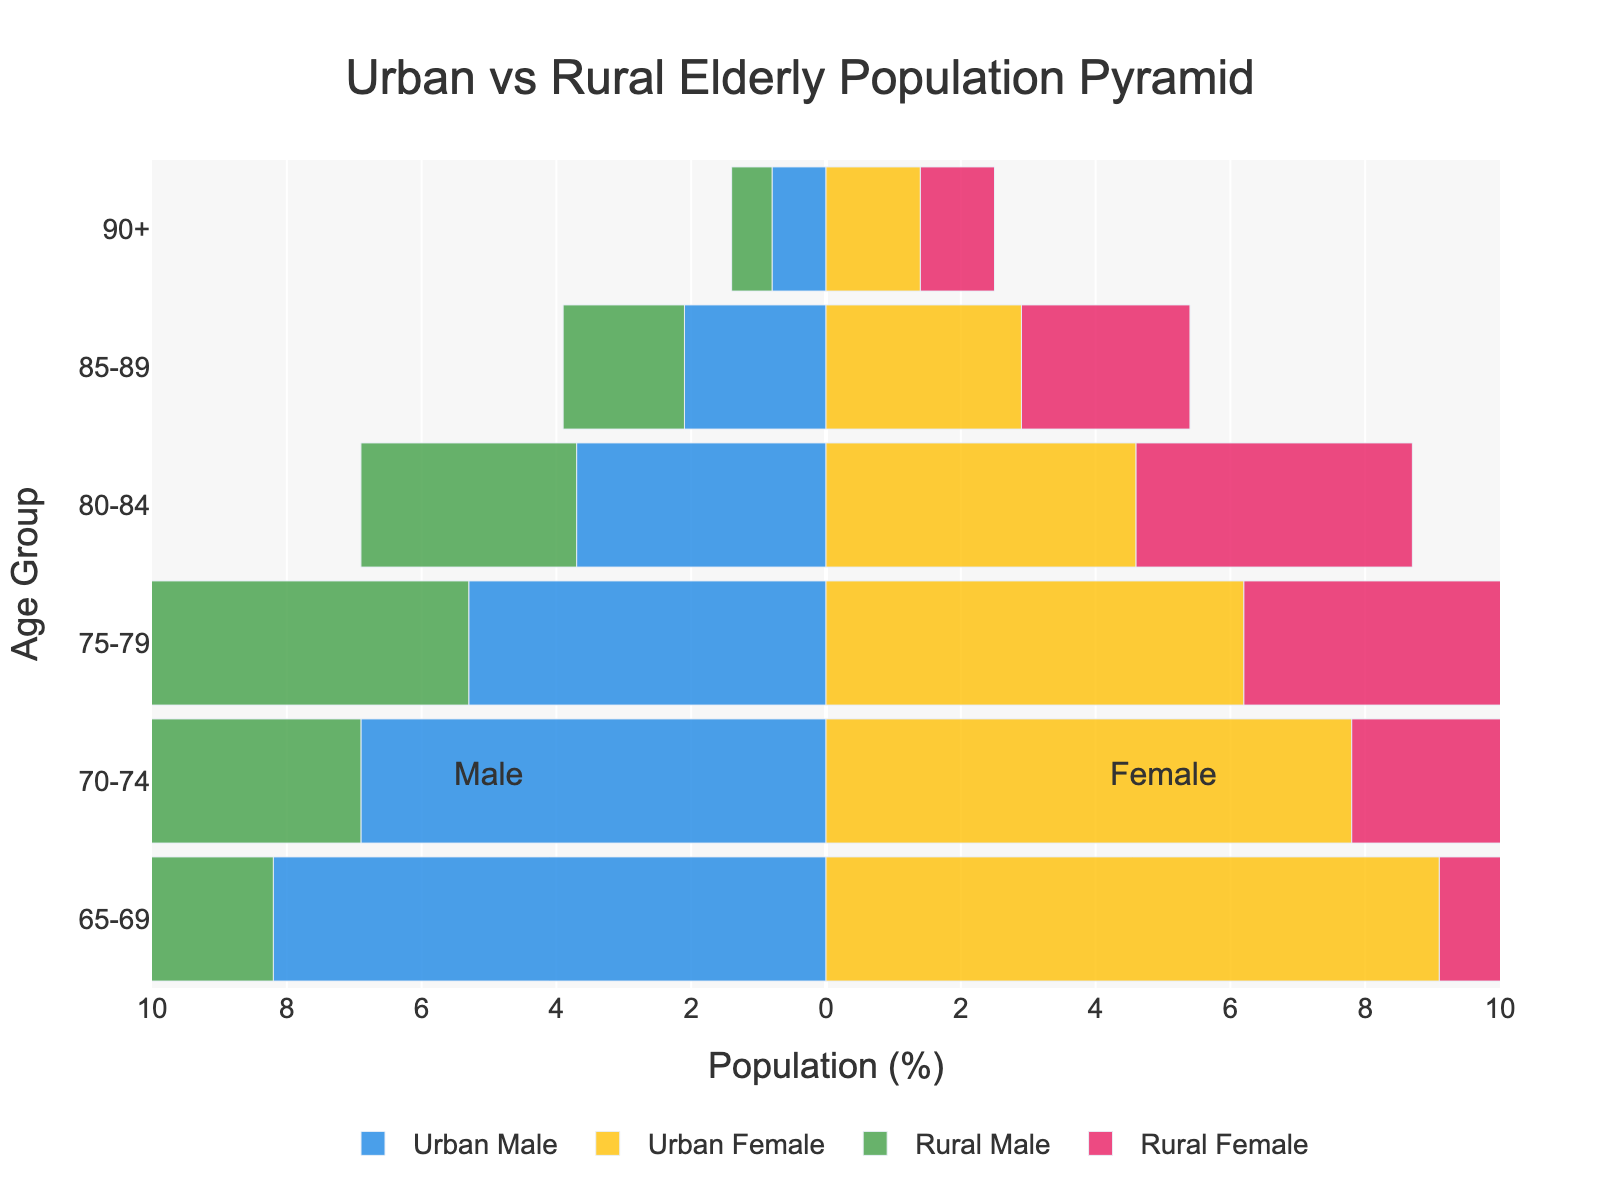What is the title of the figure? The title is usually located at the top of the figure and provides a summary of what the chart represents. In this case, the title reads "Urban vs Rural Elderly Population Pyramid", as indicated by the 'title' parameter in the code.
Answer: Urban vs Rural Elderly Population Pyramid What is the percentage of Rural Females in the 70-74 age group? To answer this, you look at the part of the population pyramid corresponding to the "70-74" age group and the bar associated with "Rural Female". According to the provided data, it is 7.1%.
Answer: 7.1% Which group has a higher population percentage in the 65-69 age range, Urban Males or Rural Males? For this, you compare the lengths of the bars for "Urban Male" and "Rural Male" in the "65-69" age group. According to the data, Urban Males are 8.2% and Rural Males are 7.5%, so Urban Males have a higher percentage.
Answer: Urban Males How many age groups have a higher population percentage of Urban Females compared to Urban Males? To find this, compare the population percentages of Urban Females and Urban Males for each age group: 65-69 (9.1 > 8.2), 70-74 (7.8 > 6.9), 75-79 (6.2 > 5.3), 80-84 (4.6 > 3.7), 85-89 (2.9 > 2.1), and 90+ (1.4 > 0.8). All 6 age groups have higher percentages of Urban Females.
Answer: 6 What is the population difference between Rural Males and Rural Females in the 85-89 age group? Subtract the percentage of Rural Males from that of Rural Females in the "85-89" age group: 2.5 - 1.8 = 0.7%.
Answer: 0.7% In which age group do Rural Females have the lowest population percentage? By looking at the length of the bars for "Rural Female" in each age group, you find that the "90+" age group has the lowest percentage at 1.1%.
Answer: 90+ Are there more Urban Males or Rural Males in the 80-84 age range? Compare the percentages of Urban Males and Rural Males in the 80-84 age group: Urban Males are 3.7% and Rural Males are 3.2%. Thus, there are more Urban Males.
Answer: Urban Males Which gender has a larger population in the urban areas for the age group 75-79? Compare the percentage of Urban Females (6.2%) to Urban Males (5.3%) for the age group 75-79. Urban Females have a larger population.
Answer: Urban Females What is the range of values shown on the x-axis of the population pyramid? The x-axis range is indicated by the tick values, which span from -10 to 10. This reflects the population percentages for males (negative values) and females (positive values) on the chart.
Answer: -10 to 10 For the age group 70-74, is the population percentage higher in urban or rural elderly populations for each gender? Compare the percentages for both genders in the age group 70-74. Urban Male (6.9%) vs Rural Male (6.2%) and Urban Female (7.8%) vs Rural Female (7.1%). In both cases, the urban population has a higher percentage.
Answer: Urban 